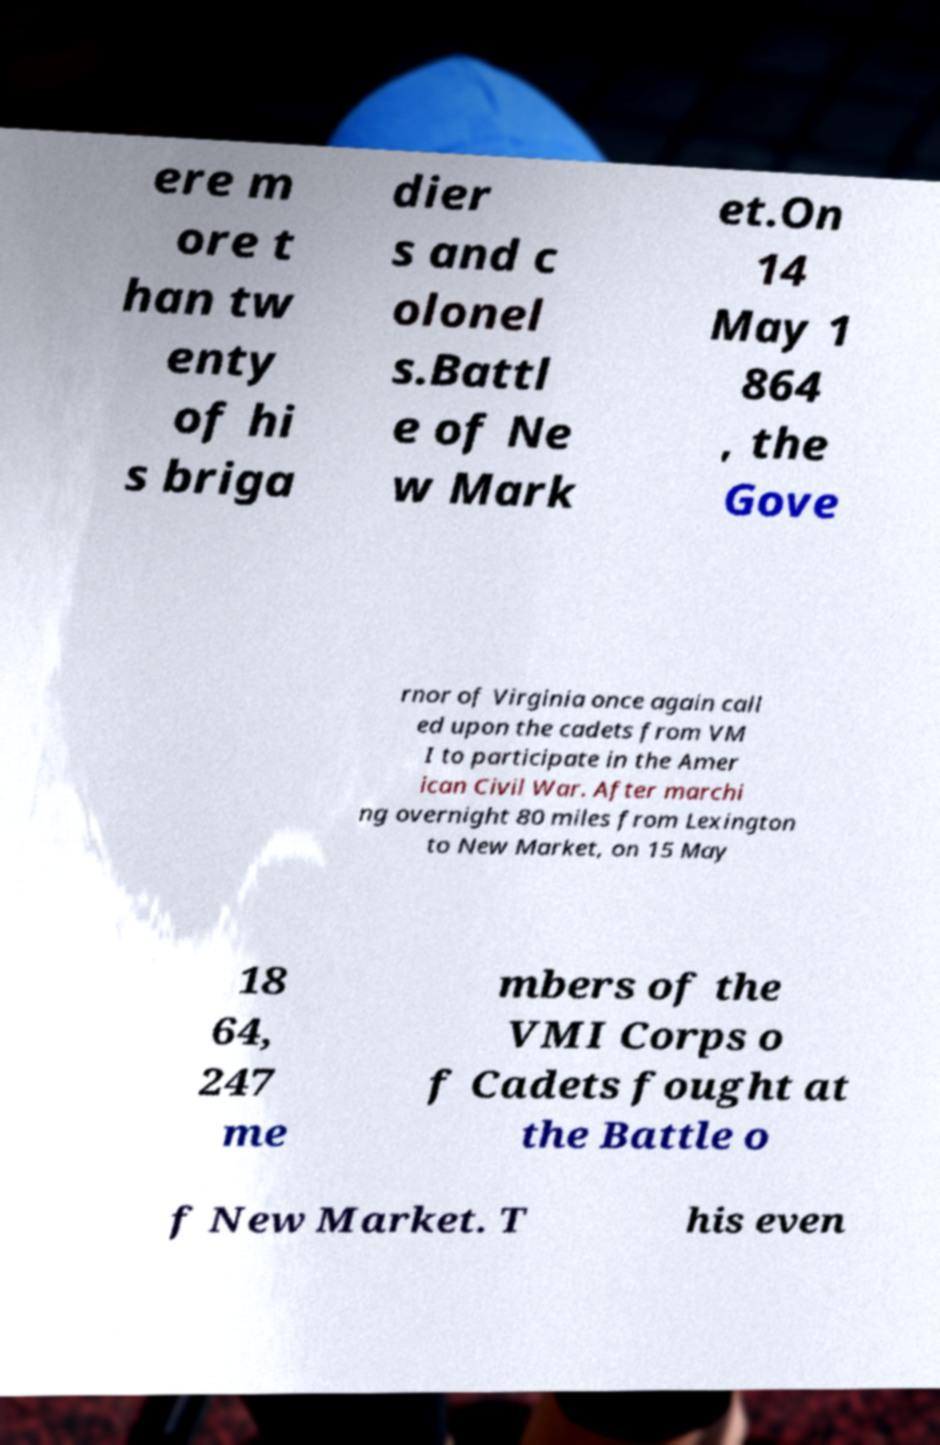Can you read and provide the text displayed in the image?This photo seems to have some interesting text. Can you extract and type it out for me? ere m ore t han tw enty of hi s briga dier s and c olonel s.Battl e of Ne w Mark et.On 14 May 1 864 , the Gove rnor of Virginia once again call ed upon the cadets from VM I to participate in the Amer ican Civil War. After marchi ng overnight 80 miles from Lexington to New Market, on 15 May 18 64, 247 me mbers of the VMI Corps o f Cadets fought at the Battle o f New Market. T his even 